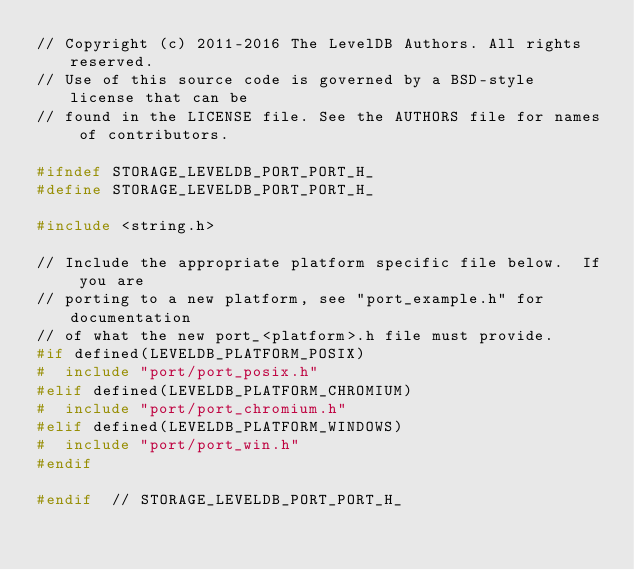<code> <loc_0><loc_0><loc_500><loc_500><_C_>// Copyright (c) 2011-2016 The LevelDB Authors. All rights reserved.
// Use of this source code is governed by a BSD-style license that can be
// found in the LICENSE file. See the AUTHORS file for names of contributors.

#ifndef STORAGE_LEVELDB_PORT_PORT_H_
#define STORAGE_LEVELDB_PORT_PORT_H_

#include <string.h>

// Include the appropriate platform specific file below.  If you are
// porting to a new platform, see "port_example.h" for documentation
// of what the new port_<platform>.h file must provide.
#if defined(LEVELDB_PLATFORM_POSIX)
#  include "port/port_posix.h"
#elif defined(LEVELDB_PLATFORM_CHROMIUM)
#  include "port/port_chromium.h"
#elif defined(LEVELDB_PLATFORM_WINDOWS)
#  include "port/port_win.h"
#endif

#endif  // STORAGE_LEVELDB_PORT_PORT_H_
</code> 